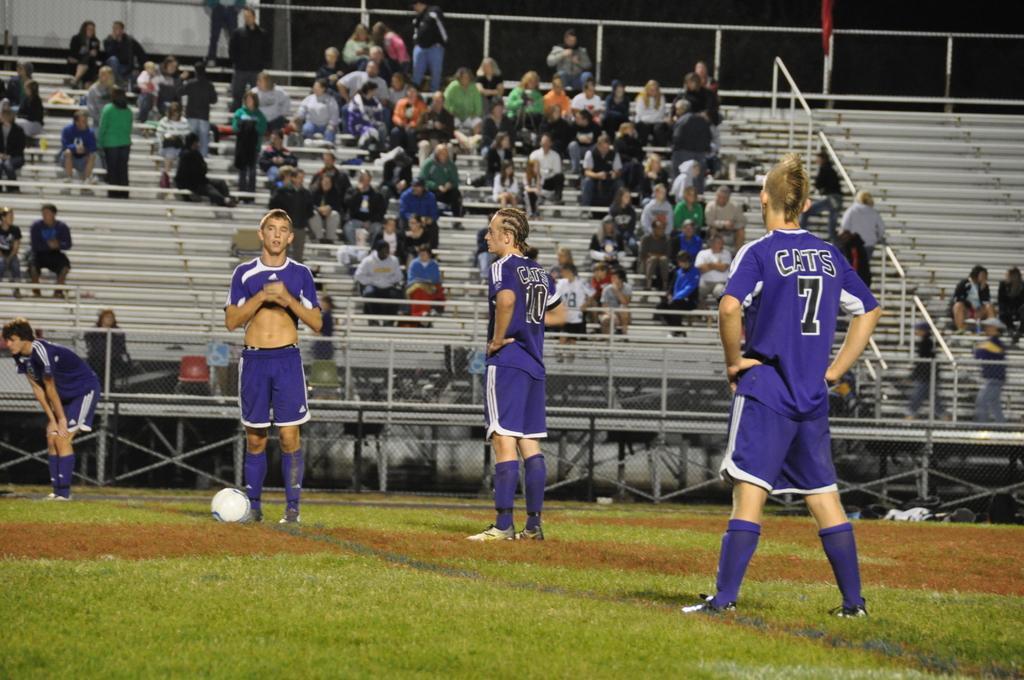Describe this image in one or two sentences. In this image I can see group of people standing and they are wearing white and purple color jersey. Background I can see few people sitting on the stairs and I can also see the railing. 